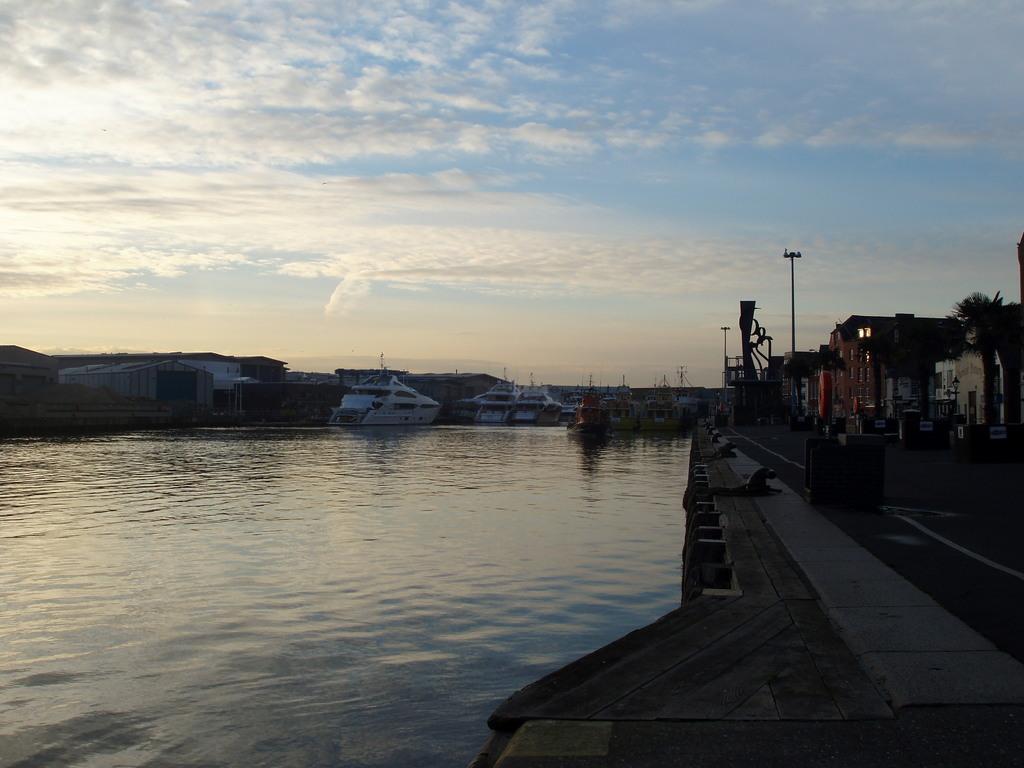How would you summarize this image in a sentence or two? In this image we can see boats on the water. Also there are buildings. And there is a road. In the background there is sky with clouds. 